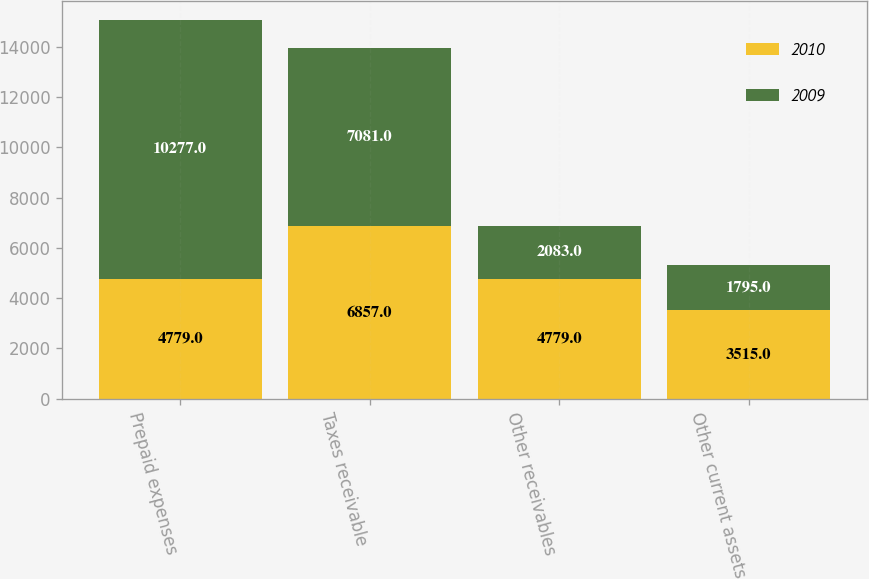<chart> <loc_0><loc_0><loc_500><loc_500><stacked_bar_chart><ecel><fcel>Prepaid expenses<fcel>Taxes receivable<fcel>Other receivables<fcel>Other current assets<nl><fcel>2010<fcel>4779<fcel>6857<fcel>4779<fcel>3515<nl><fcel>2009<fcel>10277<fcel>7081<fcel>2083<fcel>1795<nl></chart> 